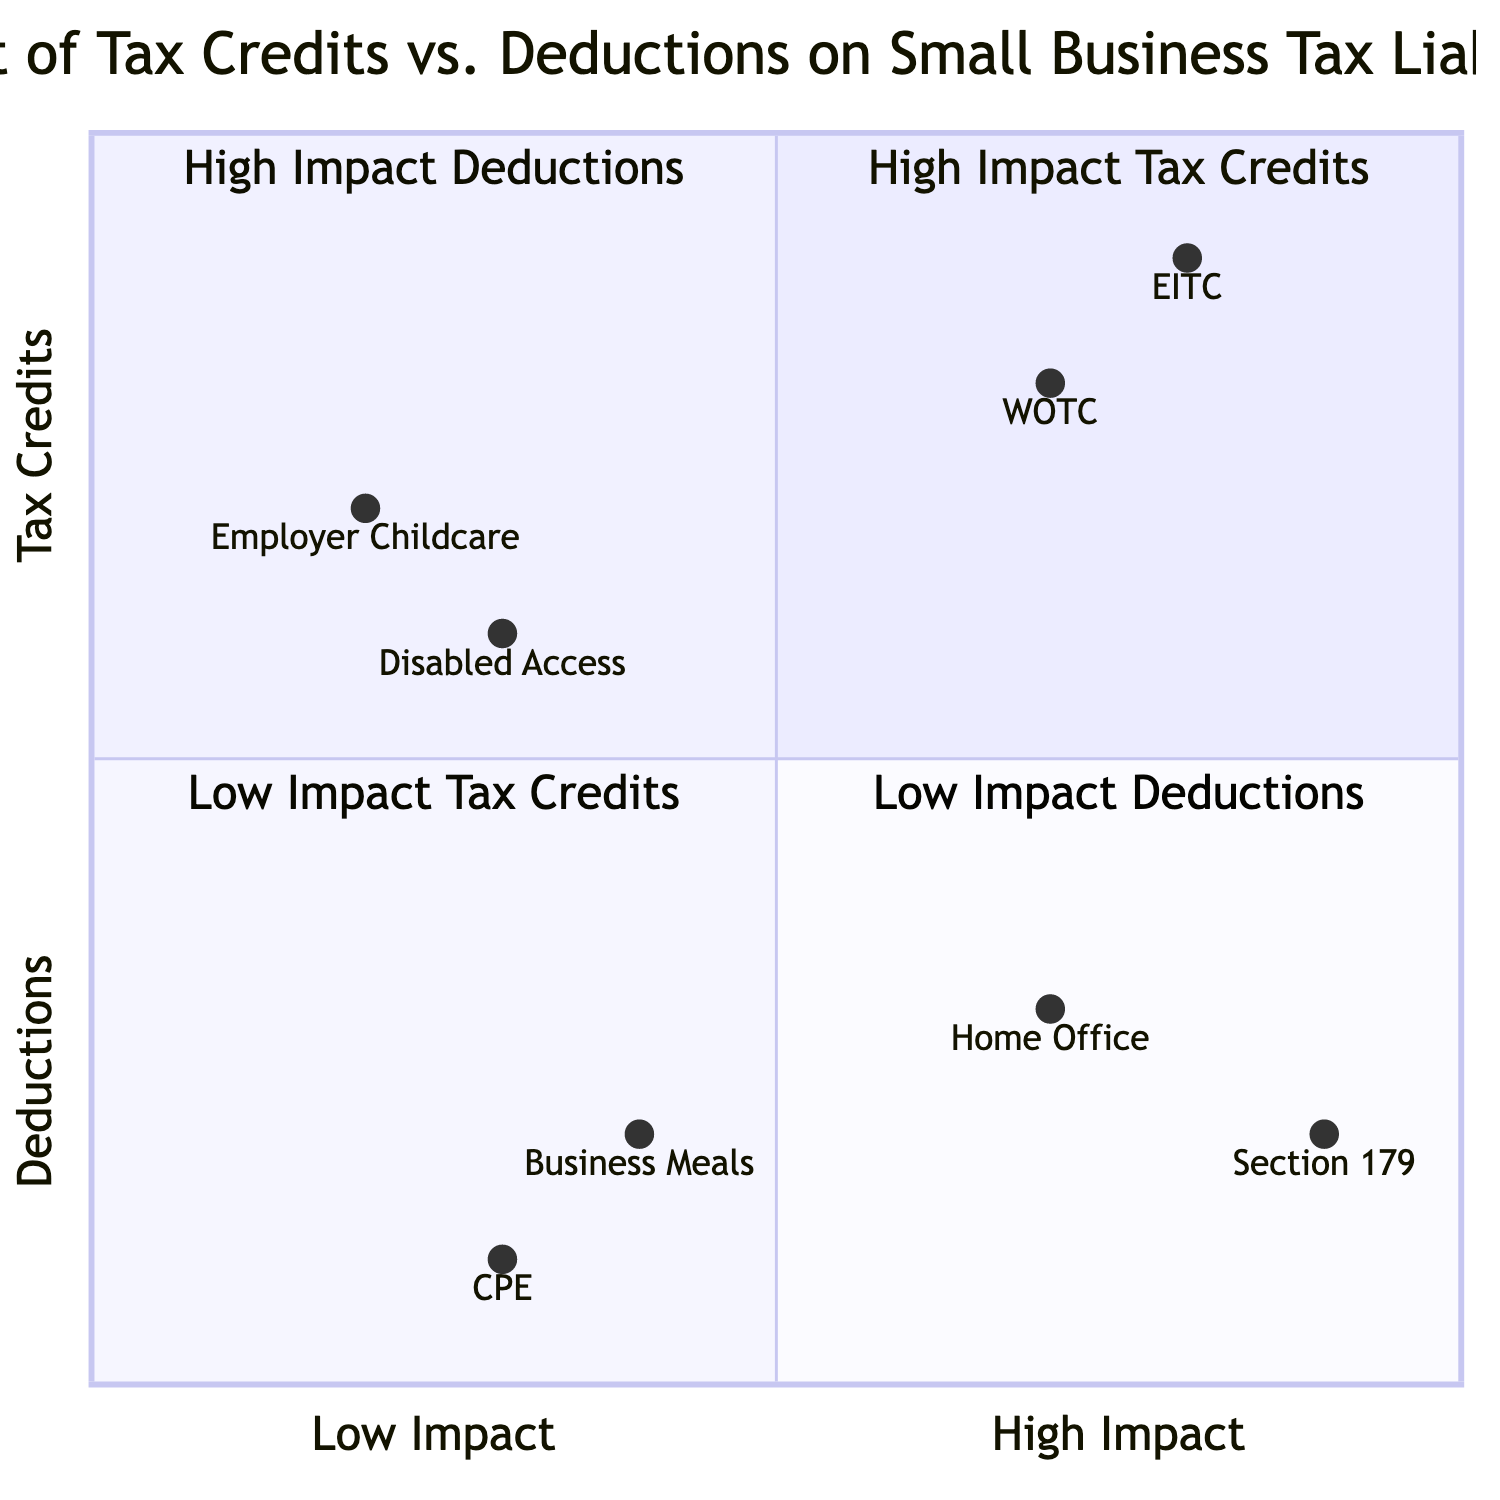What are the elements in the High Impact Tax Credits quadrant? The High Impact Tax Credits quadrant (Q1) includes the Earned Income Tax Credit (EITC) and the Work Opportunity Tax Credit (WOTC).
Answer: EITC, WOTC Which quadrant has the Section 179 Deduction? The Section 179 Deduction is located in the High Impact Deductions quadrant (Q2).
Answer: Q2 How many total elements are there in the Low Impact Deductions quadrant? The Low Impact Deductions quadrant (Q4) includes two elements: Business Meals Deduction and Continuing Professional Education Expenses, totaling two elements.
Answer: 2 Which tax credit has the highest impact rating? The Earned Income Tax Credit (EITC) is positioned in the High Impact Tax Credits quadrant and has the highest impact rating.
Answer: EITC Which deduction has the lowest impact rating? The Continuing Professional Education (CPE) Expenses is located in the Low Impact Deductions quadrant and has the lowest impact rating.
Answer: CPE Which tax credit is categorized as having minimal effect? The Disabled Access Credit is classified in the Low Impact Tax Credits quadrant (Q3), indicating its minimal effect.
Answer: Disabled Access Credit What is the position of the Work Opportunity Tax Credit in the chart? The Work Opportunity Tax Credit (WOTC) has a coordinate position of [0.7, 0.8], indicating it is in the upper right of the chart, specifically in the High Impact Tax Credits quadrant.
Answer: [0.7, 0.8] Which quadrant features the Home Office Deduction? The Home Office Deduction is part of the High Impact Deductions quadrant (Q2) in the diagram.
Answer: Q2 Which two elements have the same y-axis value? The Home Office Deduction and the Disabled Access Credit both have a y-axis value of approximately 0.3 to 0.6, but they are in different quadrants.
Answer: Home Office Deduction, Disabled Access Credit 